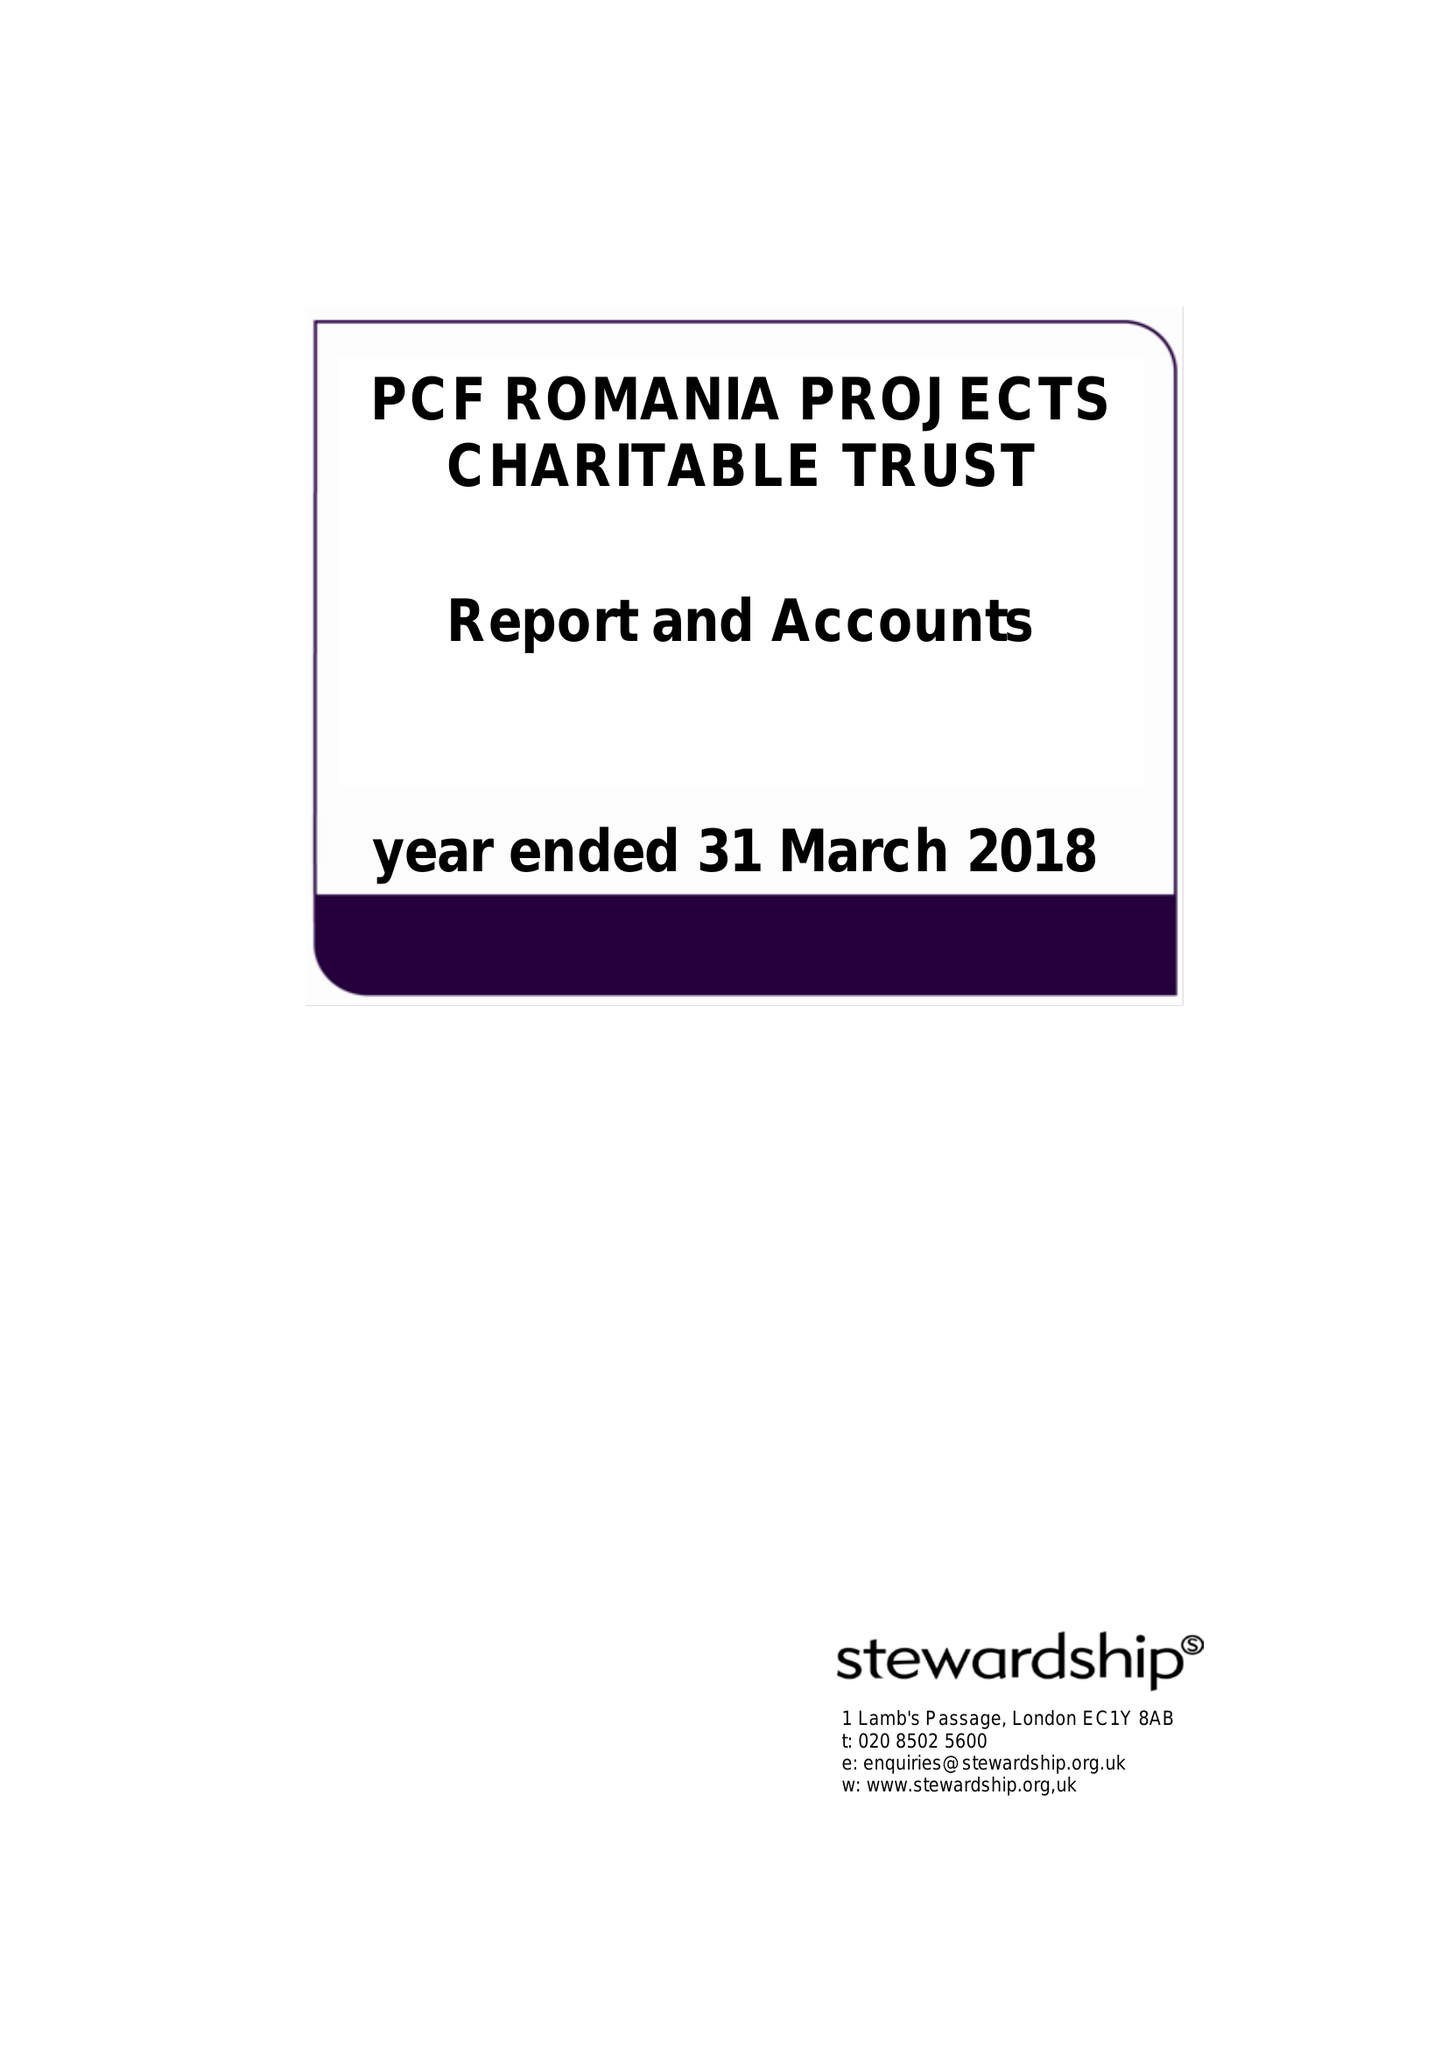What is the value for the income_annually_in_british_pounds?
Answer the question using a single word or phrase. 72504.00 